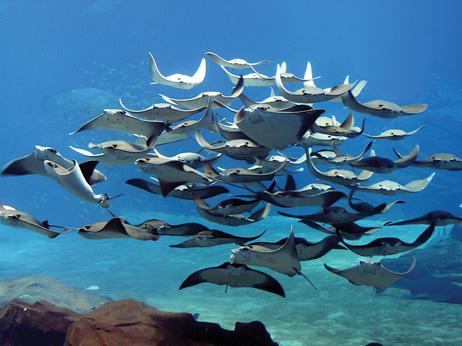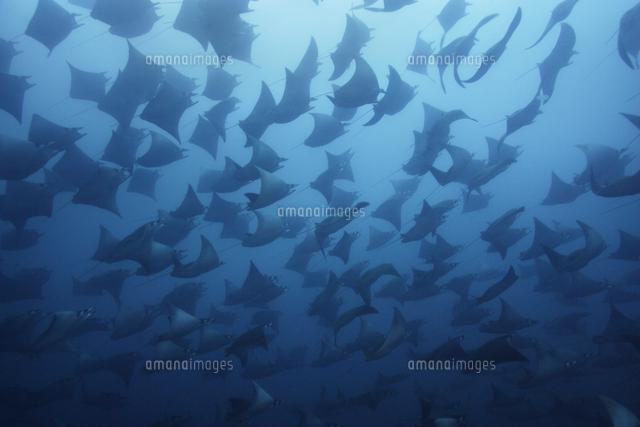The first image is the image on the left, the second image is the image on the right. Given the left and right images, does the statement "The left image contains no more than five sting rays." hold true? Answer yes or no. No. 